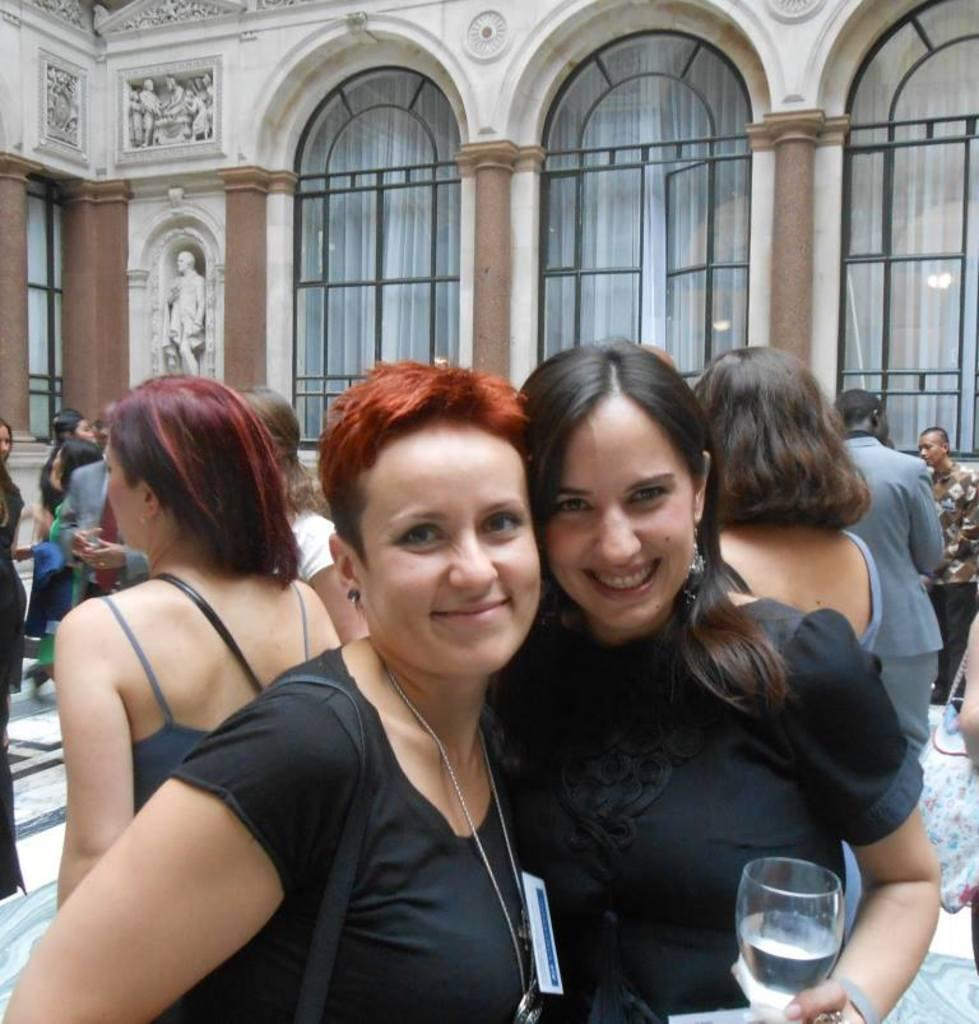What can be observed about the people in the image? There are people standing in the image. Can you describe the women in the image? There are two women in the image, and they are both smiling. What is one of the women holding? One of the women is holding a glass. What type of pest can be seen on the plantation in the image? There is no plantation or pest present in the image. Can you tell me how many monkeys are visible in the image? There are no monkeys present in the image. 